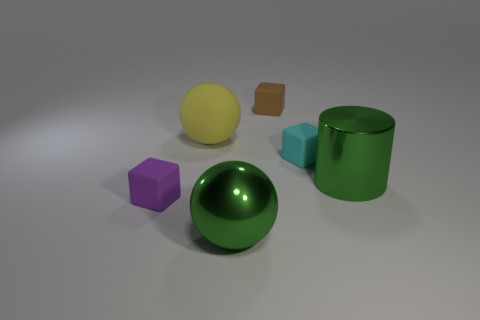Add 2 large green things. How many objects exist? 8 Subtract all spheres. How many objects are left? 4 Add 6 big green metallic cylinders. How many big green metallic cylinders are left? 7 Add 3 cyan objects. How many cyan objects exist? 4 Subtract 1 green balls. How many objects are left? 5 Subtract all big green cylinders. Subtract all small cyan rubber things. How many objects are left? 4 